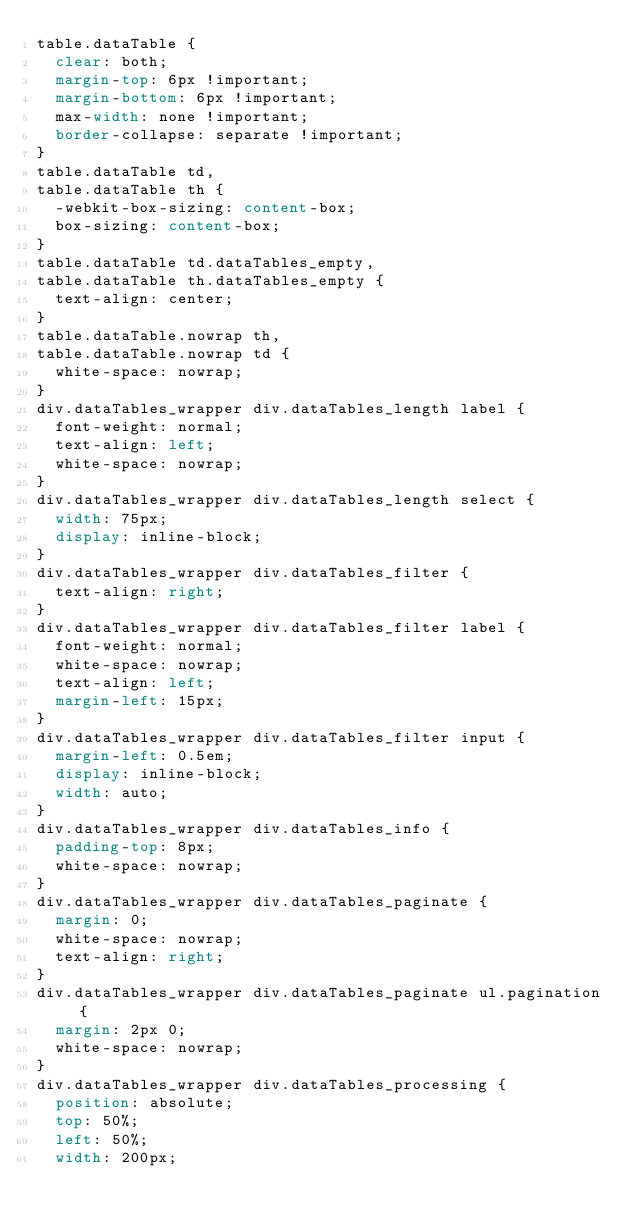Convert code to text. <code><loc_0><loc_0><loc_500><loc_500><_CSS_>table.dataTable {
  clear: both;
  margin-top: 6px !important;
  margin-bottom: 6px !important;
  max-width: none !important;
  border-collapse: separate !important;
}
table.dataTable td,
table.dataTable th {
  -webkit-box-sizing: content-box;
  box-sizing: content-box;
}
table.dataTable td.dataTables_empty,
table.dataTable th.dataTables_empty {
  text-align: center;
}
table.dataTable.nowrap th,
table.dataTable.nowrap td {
  white-space: nowrap;
}
div.dataTables_wrapper div.dataTables_length label {
  font-weight: normal;
  text-align: left;
  white-space: nowrap;
}
div.dataTables_wrapper div.dataTables_length select {
  width: 75px;
  display: inline-block;
}
div.dataTables_wrapper div.dataTables_filter {
  text-align: right;
}
div.dataTables_wrapper div.dataTables_filter label {
  font-weight: normal;
  white-space: nowrap;
  text-align: left;
  margin-left: 15px;
}
div.dataTables_wrapper div.dataTables_filter input {
  margin-left: 0.5em;
  display: inline-block;
  width: auto;
}
div.dataTables_wrapper div.dataTables_info {
  padding-top: 8px;
  white-space: nowrap;
}
div.dataTables_wrapper div.dataTables_paginate {
  margin: 0;
  white-space: nowrap;
  text-align: right;
}
div.dataTables_wrapper div.dataTables_paginate ul.pagination {
  margin: 2px 0;
  white-space: nowrap;
}
div.dataTables_wrapper div.dataTables_processing {
  position: absolute;
  top: 50%;
  left: 50%;
  width: 200px;</code> 